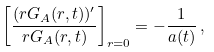Convert formula to latex. <formula><loc_0><loc_0><loc_500><loc_500>\left [ \frac { ( r G _ { A } ( r , t ) ) ^ { \prime } } { r G _ { A } ( r , t ) } \right ] _ { r = 0 } = - \frac { 1 } { a ( t ) } \, ,</formula> 